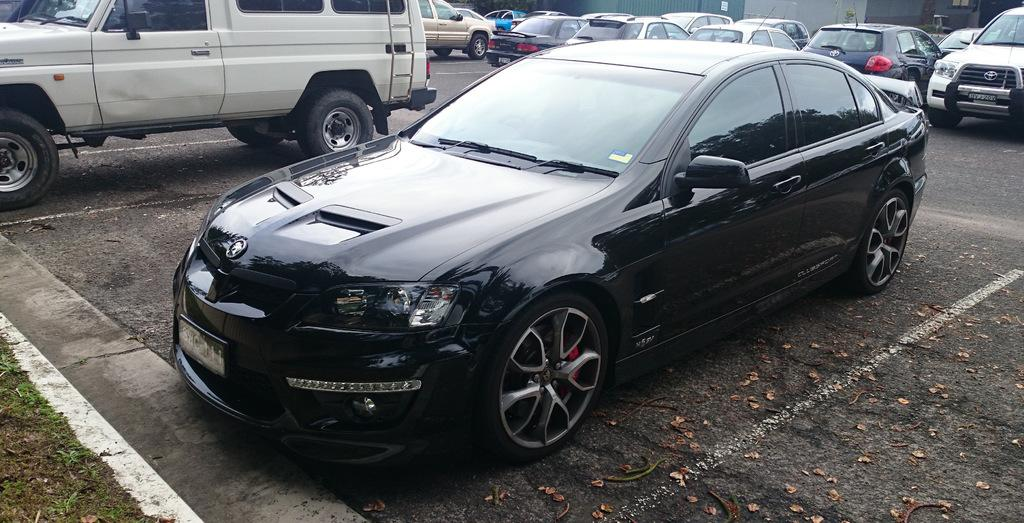What can be seen in the image in terms of transportation? There are many vehicles parked in the image. What type of location is depicted in the image? This is a road in the image. What markings are present on the road? There are white lines on the road. What type of vegetation is visible in the image? There is grass visible in the image. What features of the vehicles are visible in the image? The headlights and number plates of the vehicles are visible. What is the tendency of the teeth in the image to move around? There are no teeth present in the image, so it is not possible to determine their tendency to move around. 